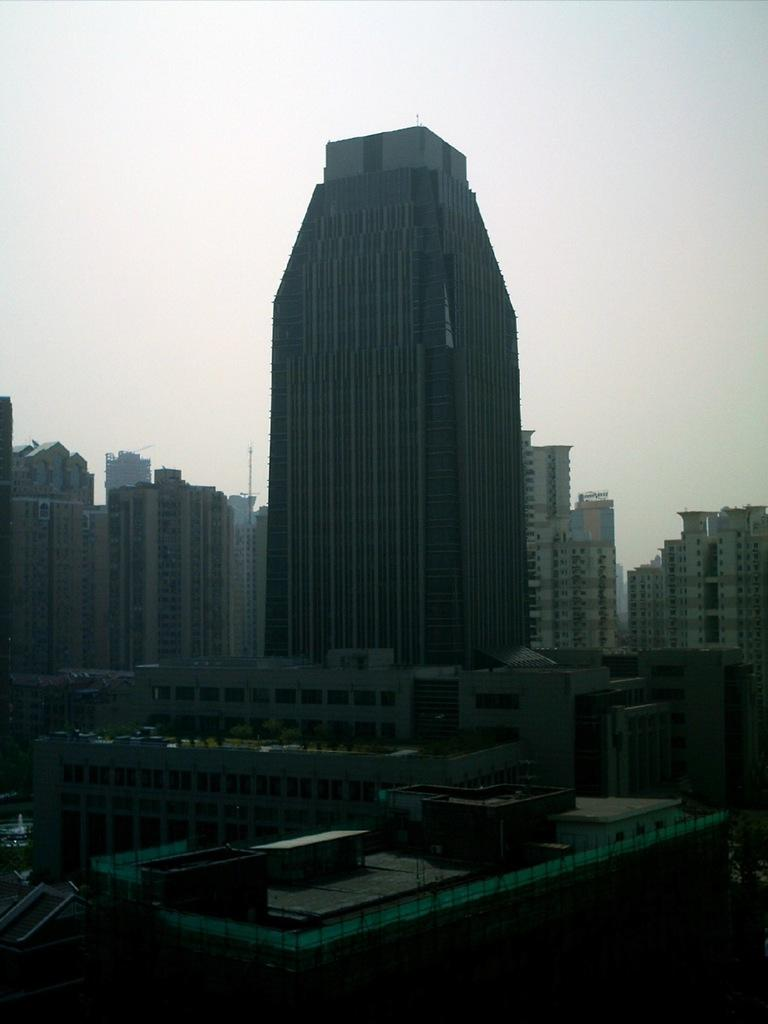What is the main structure in the picture? There is a tower building in the picture. Are there any other buildings visible in the image? Yes, there are other buildings around the tower building. How many servants can be seen attending to the monkey in the image? There are no servants or monkeys present in the image; it features a tower building and other surrounding buildings. 